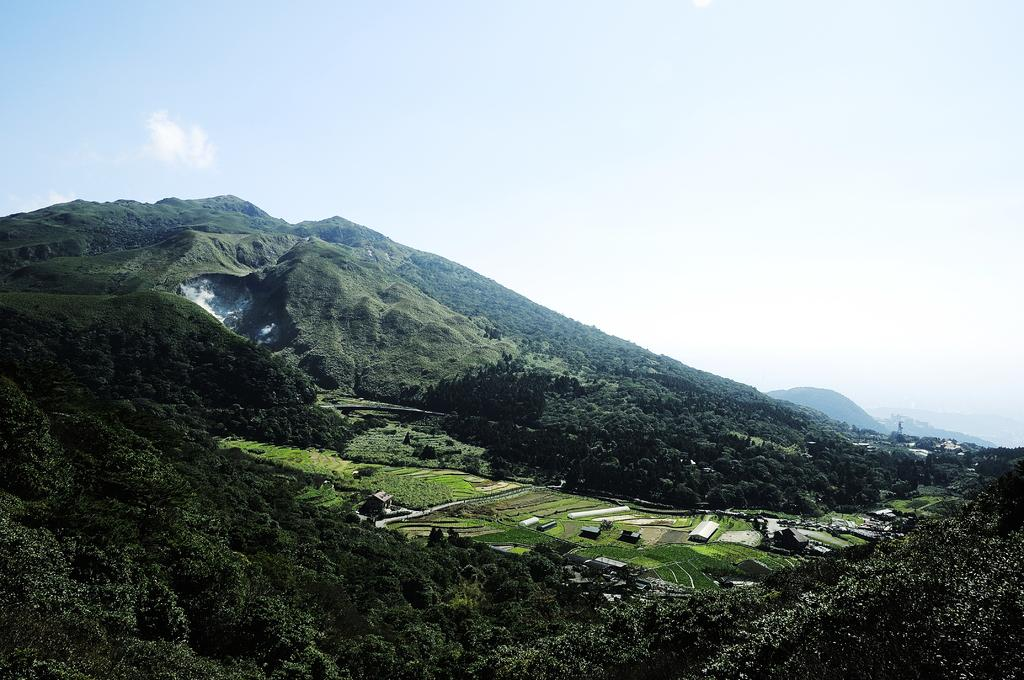What type of vegetation can be seen in the image? There are trees in the image. What type of structures are present in the image? There are houses in the image. What is the ground covered with in the image? There is grass in the image. What can be seen in the far distance in the image? Far in the distance, there are mountains. What type of cream is being used to paint the houses in the image? There is no indication in the image that the houses are being painted, nor is there any mention of cream being used. 